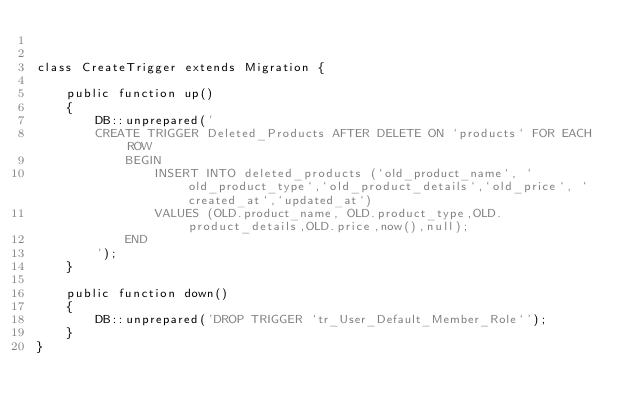<code> <loc_0><loc_0><loc_500><loc_500><_PHP_>

class CreateTrigger extends Migration {

    public function up()
    {
        DB::unprepared('
        CREATE TRIGGER Deleted_Products AFTER DELETE ON `products` FOR EACH ROW
            BEGIN
                INSERT INTO deleted_products (`old_product_name`, `old_product_type`,`old_product_details`,`old_price`, `created_at`,`updated_at`) 
                VALUES (OLD.product_name, OLD.product_type,OLD.product_details,OLD.price,now(),null);
            END
        ');
    }

    public function down()
    {
        DB::unprepared('DROP TRIGGER `tr_User_Default_Member_Role`');
    }
}
</code> 